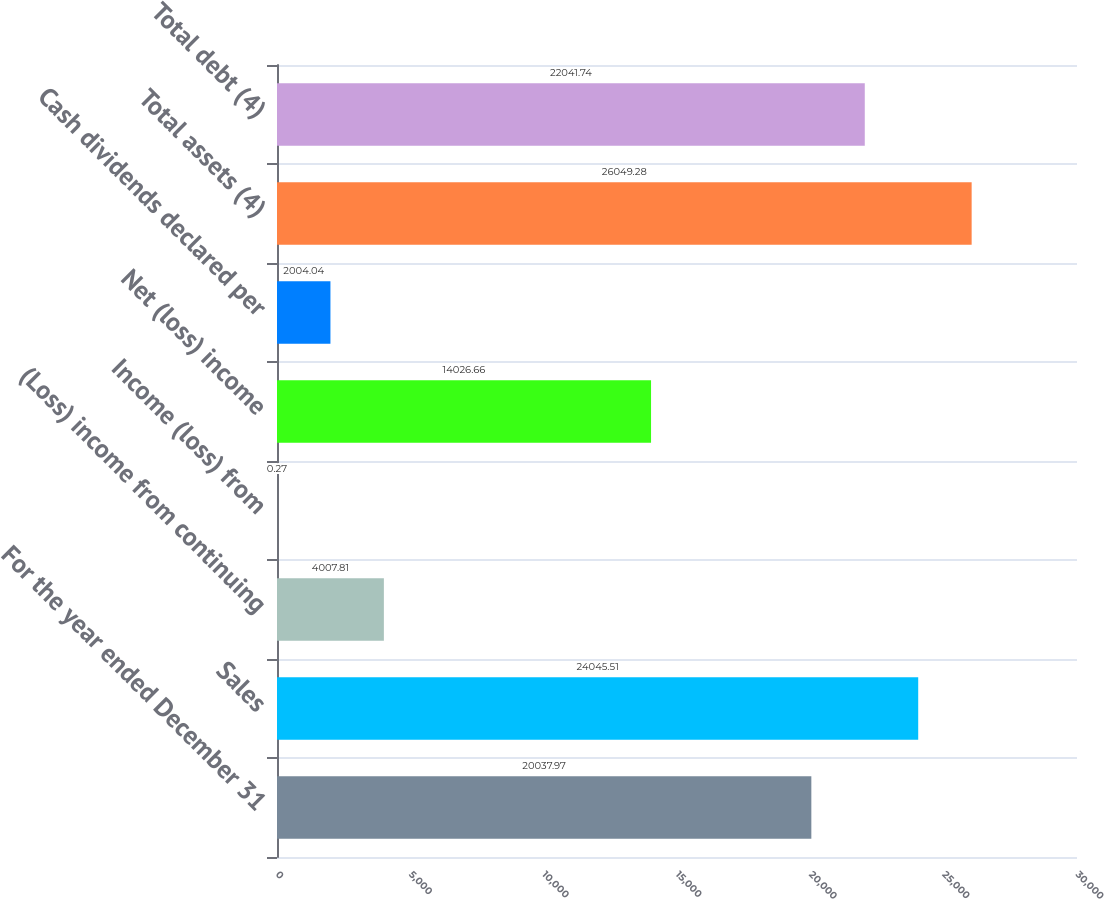Convert chart. <chart><loc_0><loc_0><loc_500><loc_500><bar_chart><fcel>For the year ended December 31<fcel>Sales<fcel>(Loss) income from continuing<fcel>Income (loss) from<fcel>Net (loss) income<fcel>Cash dividends declared per<fcel>Total assets (4)<fcel>Total debt (4)<nl><fcel>20038<fcel>24045.5<fcel>4007.81<fcel>0.27<fcel>14026.7<fcel>2004.04<fcel>26049.3<fcel>22041.7<nl></chart> 